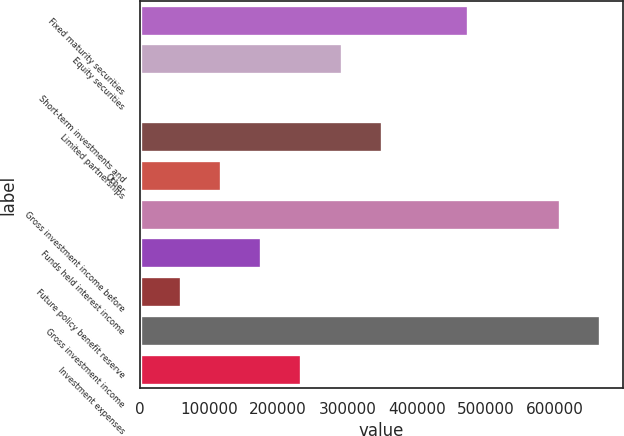Convert chart to OTSL. <chart><loc_0><loc_0><loc_500><loc_500><bar_chart><fcel>Fixed maturity securities<fcel>Equity securities<fcel>Short-term investments and<fcel>Limited partnerships<fcel>Other<fcel>Gross investment income before<fcel>Funds held interest income<fcel>Future policy benefit reserve<fcel>Gross investment income<fcel>Investment expenses<nl><fcel>473493<fcel>291782<fcel>1295<fcel>349879<fcel>117490<fcel>606606<fcel>175587<fcel>59392.3<fcel>664704<fcel>233684<nl></chart> 